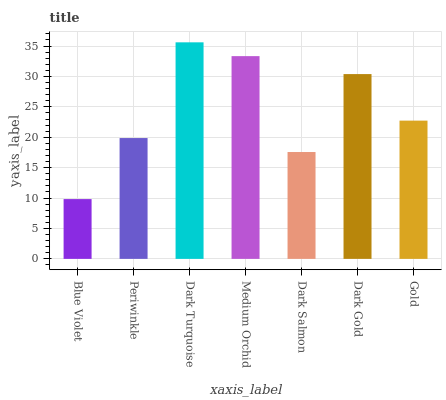Is Blue Violet the minimum?
Answer yes or no. Yes. Is Dark Turquoise the maximum?
Answer yes or no. Yes. Is Periwinkle the minimum?
Answer yes or no. No. Is Periwinkle the maximum?
Answer yes or no. No. Is Periwinkle greater than Blue Violet?
Answer yes or no. Yes. Is Blue Violet less than Periwinkle?
Answer yes or no. Yes. Is Blue Violet greater than Periwinkle?
Answer yes or no. No. Is Periwinkle less than Blue Violet?
Answer yes or no. No. Is Gold the high median?
Answer yes or no. Yes. Is Gold the low median?
Answer yes or no. Yes. Is Dark Salmon the high median?
Answer yes or no. No. Is Dark Turquoise the low median?
Answer yes or no. No. 